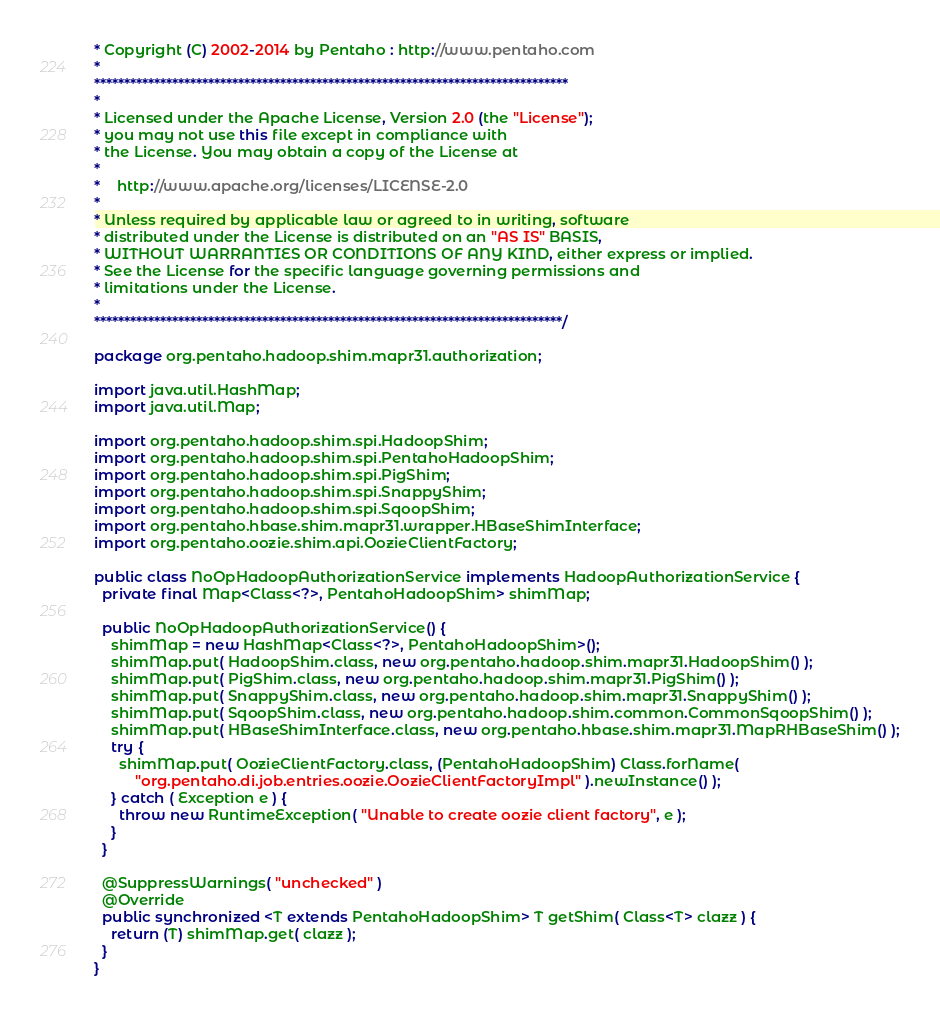<code> <loc_0><loc_0><loc_500><loc_500><_Java_>* Copyright (C) 2002-2014 by Pentaho : http://www.pentaho.com
*
*******************************************************************************
*
* Licensed under the Apache License, Version 2.0 (the "License");
* you may not use this file except in compliance with
* the License. You may obtain a copy of the License at
*
*    http://www.apache.org/licenses/LICENSE-2.0
*
* Unless required by applicable law or agreed to in writing, software
* distributed under the License is distributed on an "AS IS" BASIS,
* WITHOUT WARRANTIES OR CONDITIONS OF ANY KIND, either express or implied.
* See the License for the specific language governing permissions and
* limitations under the License.
*
******************************************************************************/

package org.pentaho.hadoop.shim.mapr31.authorization;

import java.util.HashMap;
import java.util.Map;

import org.pentaho.hadoop.shim.spi.HadoopShim;
import org.pentaho.hadoop.shim.spi.PentahoHadoopShim;
import org.pentaho.hadoop.shim.spi.PigShim;
import org.pentaho.hadoop.shim.spi.SnappyShim;
import org.pentaho.hadoop.shim.spi.SqoopShim;
import org.pentaho.hbase.shim.mapr31.wrapper.HBaseShimInterface;
import org.pentaho.oozie.shim.api.OozieClientFactory;

public class NoOpHadoopAuthorizationService implements HadoopAuthorizationService {
  private final Map<Class<?>, PentahoHadoopShim> shimMap;

  public NoOpHadoopAuthorizationService() {
    shimMap = new HashMap<Class<?>, PentahoHadoopShim>();
    shimMap.put( HadoopShim.class, new org.pentaho.hadoop.shim.mapr31.HadoopShim() );
    shimMap.put( PigShim.class, new org.pentaho.hadoop.shim.mapr31.PigShim() );
    shimMap.put( SnappyShim.class, new org.pentaho.hadoop.shim.mapr31.SnappyShim() );
    shimMap.put( SqoopShim.class, new org.pentaho.hadoop.shim.common.CommonSqoopShim() );
    shimMap.put( HBaseShimInterface.class, new org.pentaho.hbase.shim.mapr31.MapRHBaseShim() );
    try {
      shimMap.put( OozieClientFactory.class, (PentahoHadoopShim) Class.forName(
          "org.pentaho.di.job.entries.oozie.OozieClientFactoryImpl" ).newInstance() );
    } catch ( Exception e ) {
      throw new RuntimeException( "Unable to create oozie client factory", e );
    }
  }

  @SuppressWarnings( "unchecked" )
  @Override
  public synchronized <T extends PentahoHadoopShim> T getShim( Class<T> clazz ) {
    return (T) shimMap.get( clazz );
  }
}
</code> 